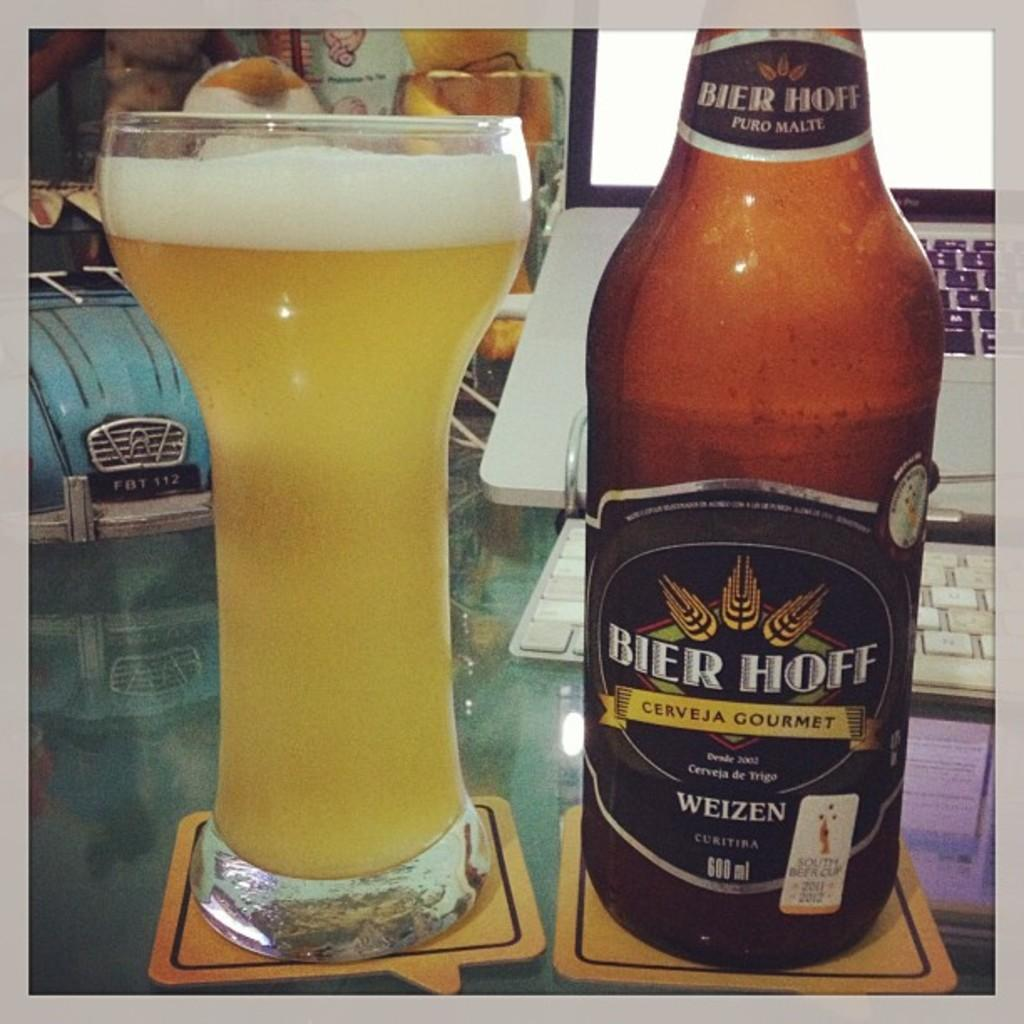What is on the table in the image? There is a glass, a wine bottle, and a laptop on the table. Can you describe the glass on the table? The glass is on the table. What is the wine bottle used for? The wine bottle is used for containing wine. What device is on the table that can be used for computing and internet access? There is a laptop on the table that can be used for computing and internet access. Can you see any berries on the table in the image? There are no berries present on the table in the image. Is the person's dad visible in the image? There is no person or dad present in the image; it only shows a table with a glass, wine bottle, and laptop. 